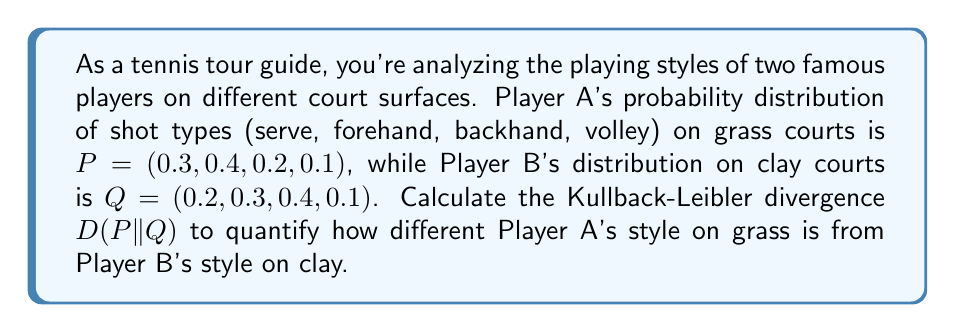Solve this math problem. To solve this problem, we need to use the formula for Kullback-Leibler (KL) divergence:

$$ D(P||Q) = \sum_{i} P(i) \log\left(\frac{P(i)}{Q(i)}\right) $$

Where P(i) and Q(i) are the probabilities of each shot type for Players A and B respectively.

Let's calculate each term of the sum:

1. For serve (i = 1):
   $P(1) = 0.3, Q(1) = 0.2$
   $0.3 \log\left(\frac{0.3}{0.2}\right) = 0.3 \log(1.5) \approx 0.1249$

2. For forehand (i = 2):
   $P(2) = 0.4, Q(2) = 0.3$
   $0.4 \log\left(\frac{0.4}{0.3}\right) = 0.4 \log(1.3333) \approx 0.1155$

3. For backhand (i = 3):
   $P(3) = 0.2, Q(3) = 0.4$
   $0.2 \log\left(\frac{0.2}{0.4}\right) = 0.2 \log(0.5) \approx -0.1386$

4. For volley (i = 4):
   $P(4) = 0.1, Q(4) = 0.1$
   $0.1 \log\left(\frac{0.1}{0.1}\right) = 0.1 \log(1) = 0$

Now, we sum all these terms:

$$ D(P||Q) = 0.1249 + 0.1155 - 0.1386 + 0 = 0.1018 $$

This value quantifies how different Player A's playing style on grass is from Player B's style on clay, in terms of information theory.
Answer: $$ D(P||Q) \approx 0.1018 \text{ bits} $$ 